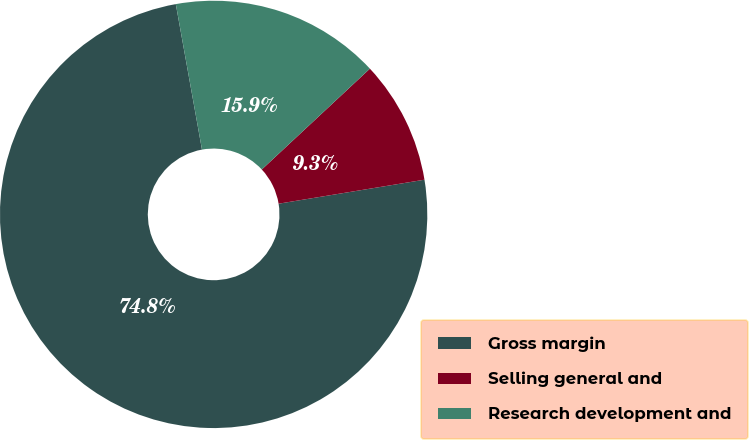Convert chart to OTSL. <chart><loc_0><loc_0><loc_500><loc_500><pie_chart><fcel>Gross margin<fcel>Selling general and<fcel>Research development and<nl><fcel>74.77%<fcel>9.35%<fcel>15.89%<nl></chart> 